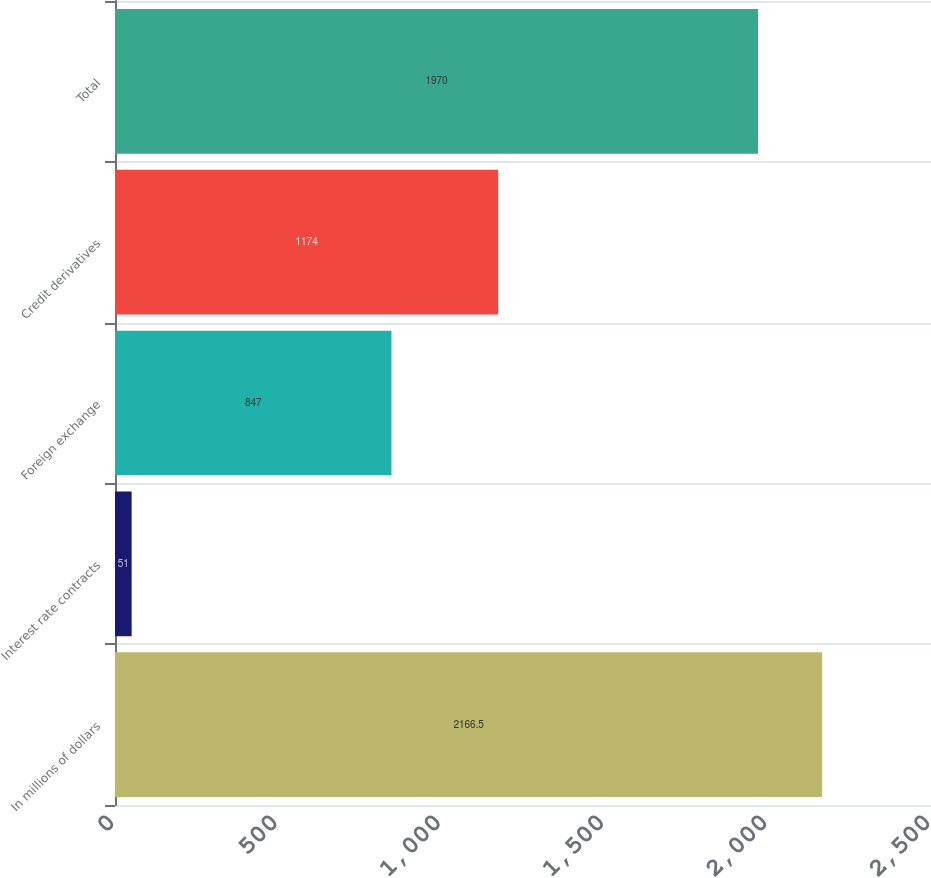<chart> <loc_0><loc_0><loc_500><loc_500><bar_chart><fcel>In millions of dollars<fcel>Interest rate contracts<fcel>Foreign exchange<fcel>Credit derivatives<fcel>Total<nl><fcel>2166.5<fcel>51<fcel>847<fcel>1174<fcel>1970<nl></chart> 